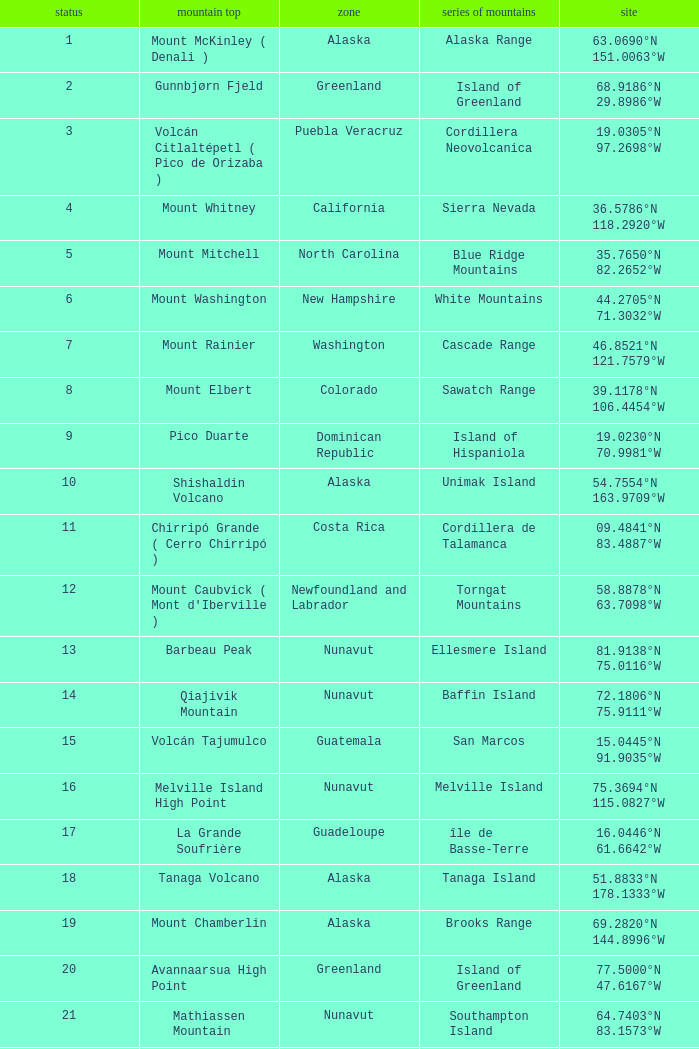Name the Mountain Peak which has a Rank of 62? Cerro Nube ( Quie Yelaag ). 